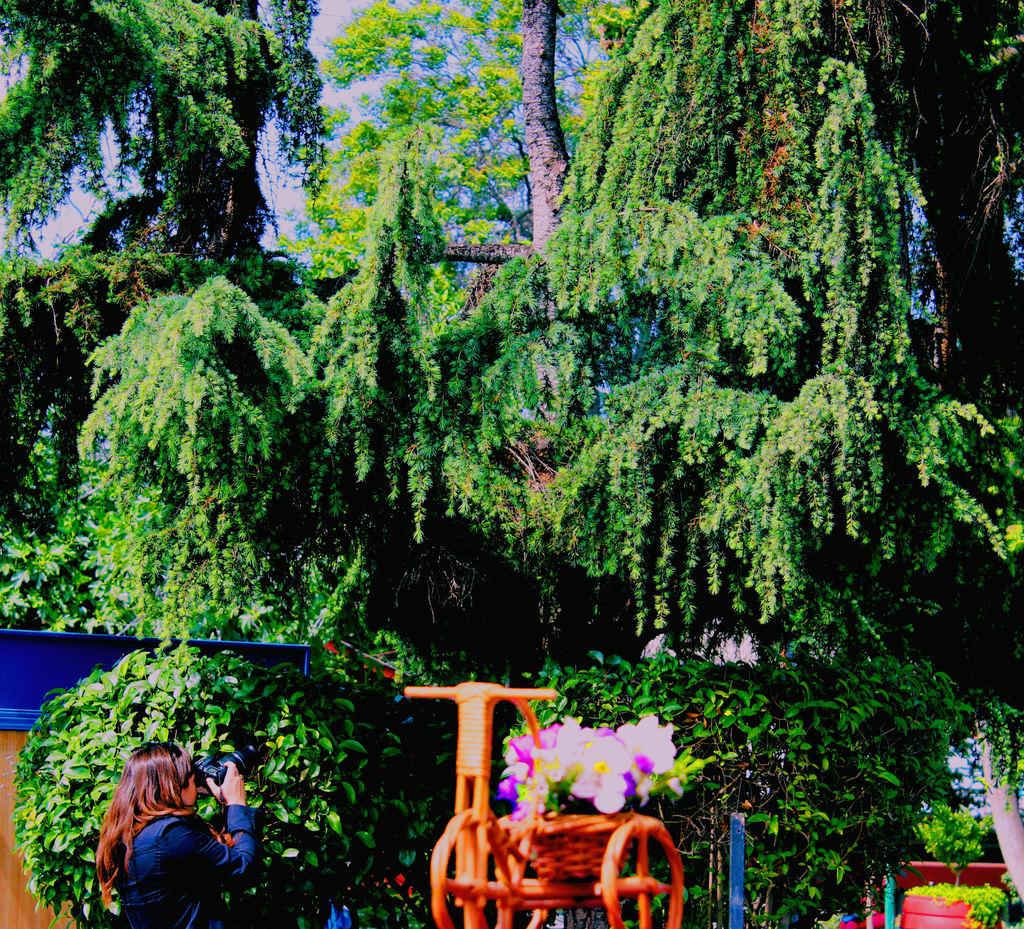What type of natural elements can be seen in the image? There are trees in the image. What is the woman in the image doing? The woman is holding a camera and taking a snap. What color is the vehicle in the image? The vehicle in the image is orange. What decorations are on the vehicle? Flowers are placed on the vehicle. What type of lip balm is the woman applying in the image? There is no lip balm or any indication of the woman applying anything to her lips in the image. 